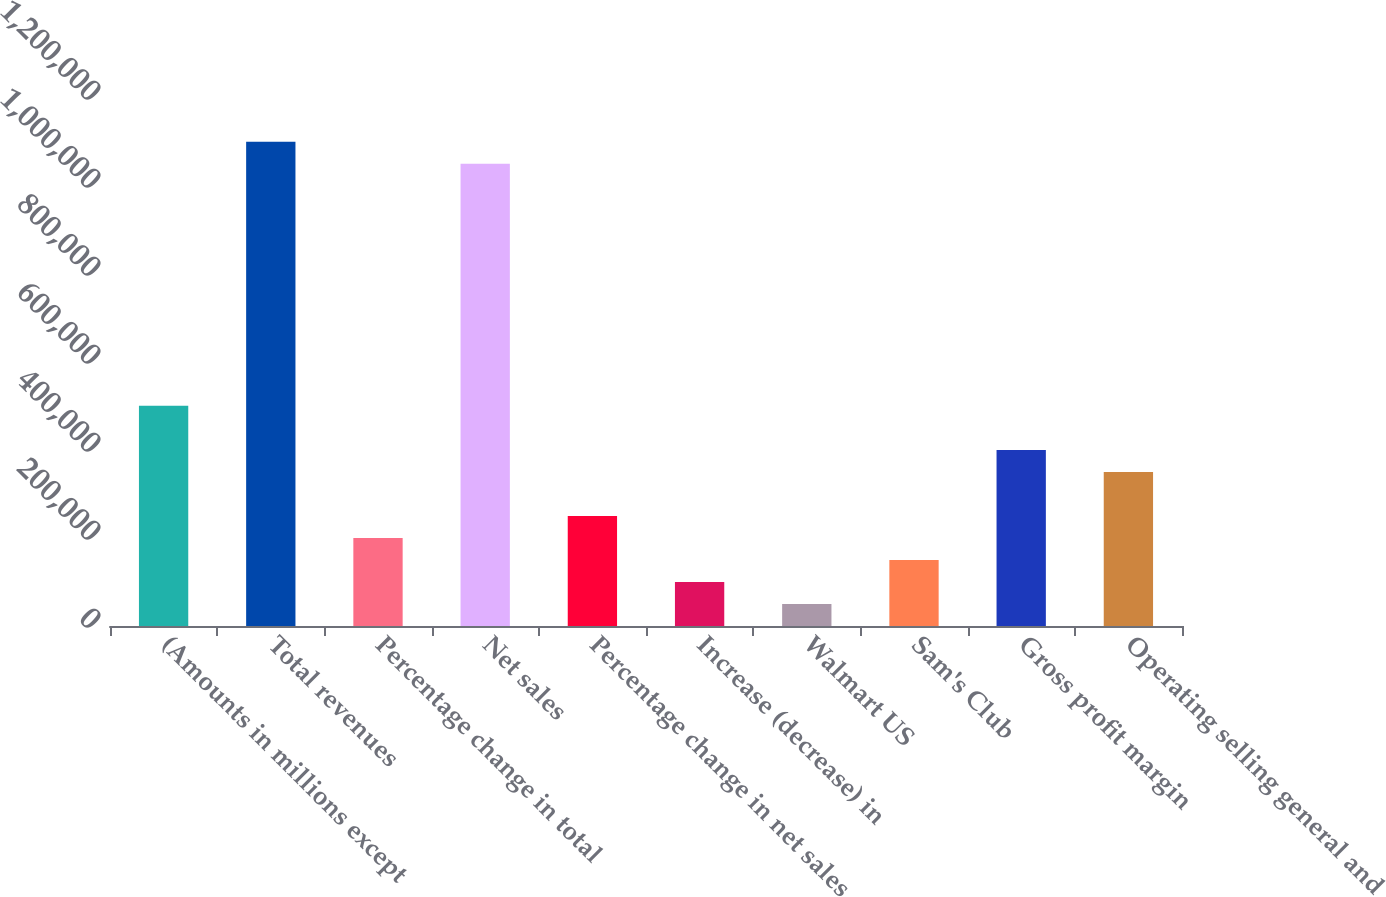Convert chart to OTSL. <chart><loc_0><loc_0><loc_500><loc_500><bar_chart><fcel>(Amounts in millions except<fcel>Total revenues<fcel>Percentage change in total<fcel>Net sales<fcel>Percentage change in net sales<fcel>Increase (decrease) in<fcel>Walmart US<fcel>Sam's Club<fcel>Gross profit margin<fcel>Operating selling general and<nl><fcel>500343<fcel>1.10075e+06<fcel>200138<fcel>1.05072e+06<fcel>250173<fcel>100070<fcel>50036.1<fcel>150104<fcel>400275<fcel>350241<nl></chart> 